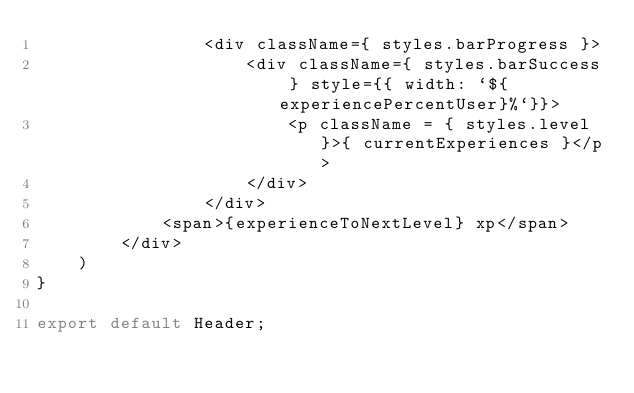<code> <loc_0><loc_0><loc_500><loc_500><_TypeScript_>                <div className={ styles.barProgress }>
                    <div className={ styles.barSuccess } style={{ width: `${experiencePercentUser}%`}}>
                        <p className = { styles.level }>{ currentExperiences }</p>
                    </div>
                </div>
            <span>{experienceToNextLevel} xp</span>
        </div>
    )
}

export default Header;</code> 